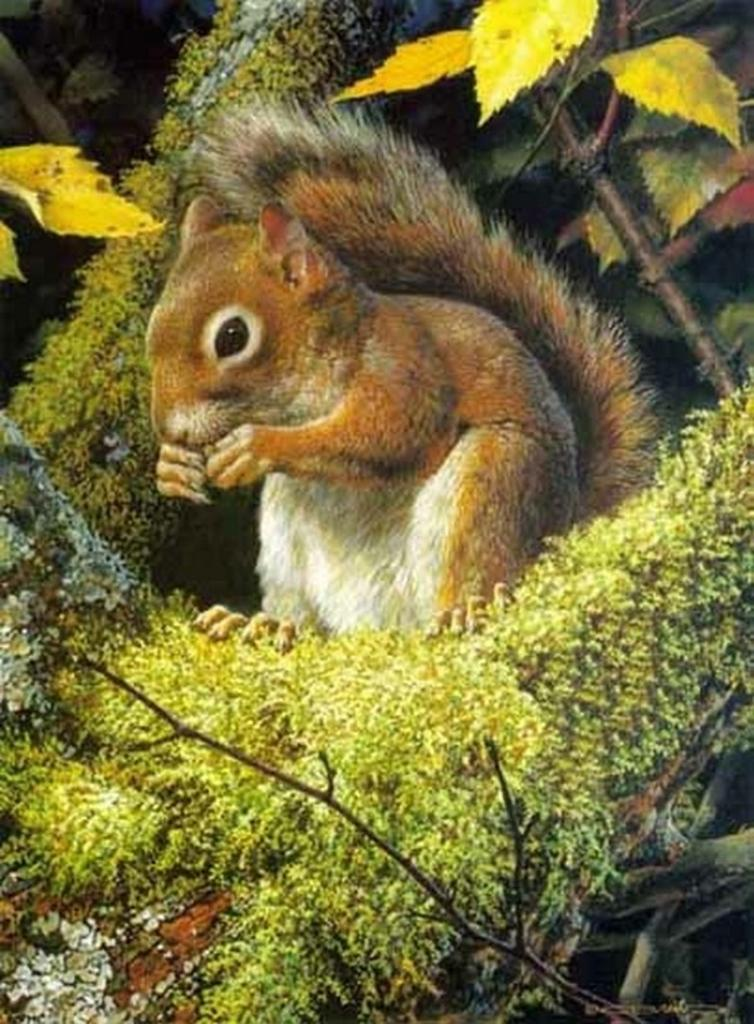What type of artwork is depicted in the image? The image is a painting. What animal can be seen in the painting? There is a squirrel in the painting. What other elements are present at the bottom of the painting? There are plants at the bottom of the painting. What fact about the rod can be learned from the painting? There is no rod present in the painting, so no fact about a rod can be learned from it. 